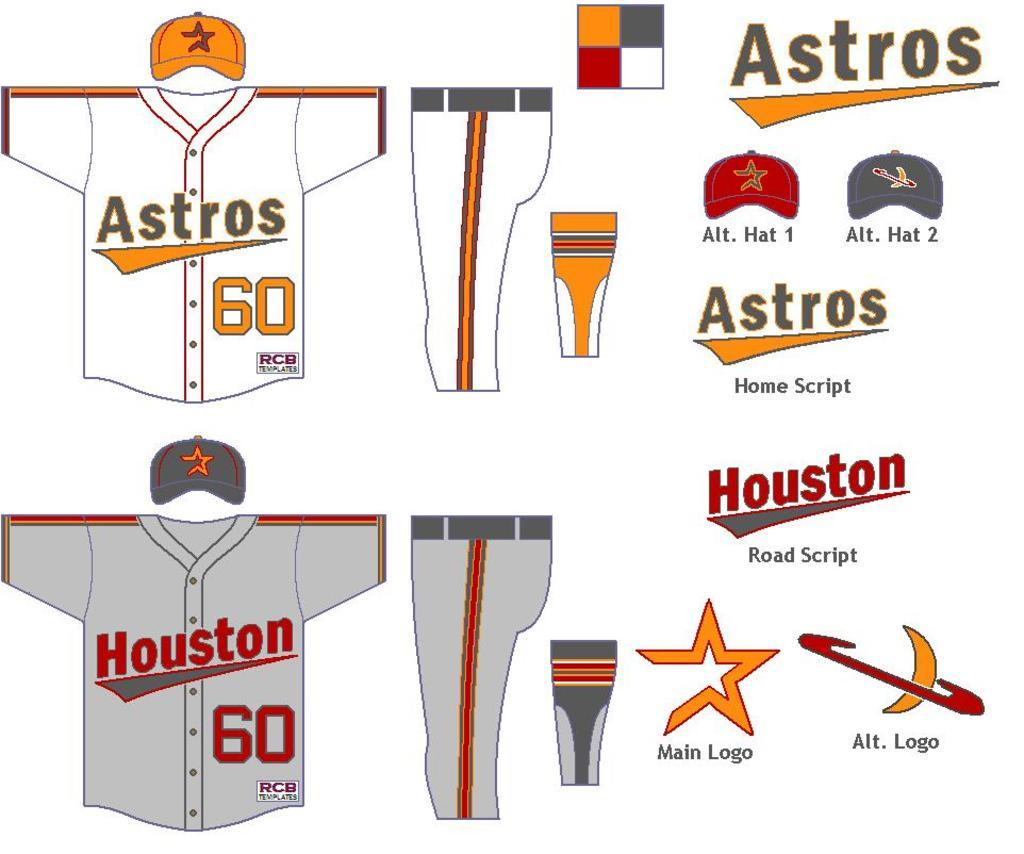<image>
Relay a brief, clear account of the picture shown. The Astros uniforms are shown from the front and side view. 